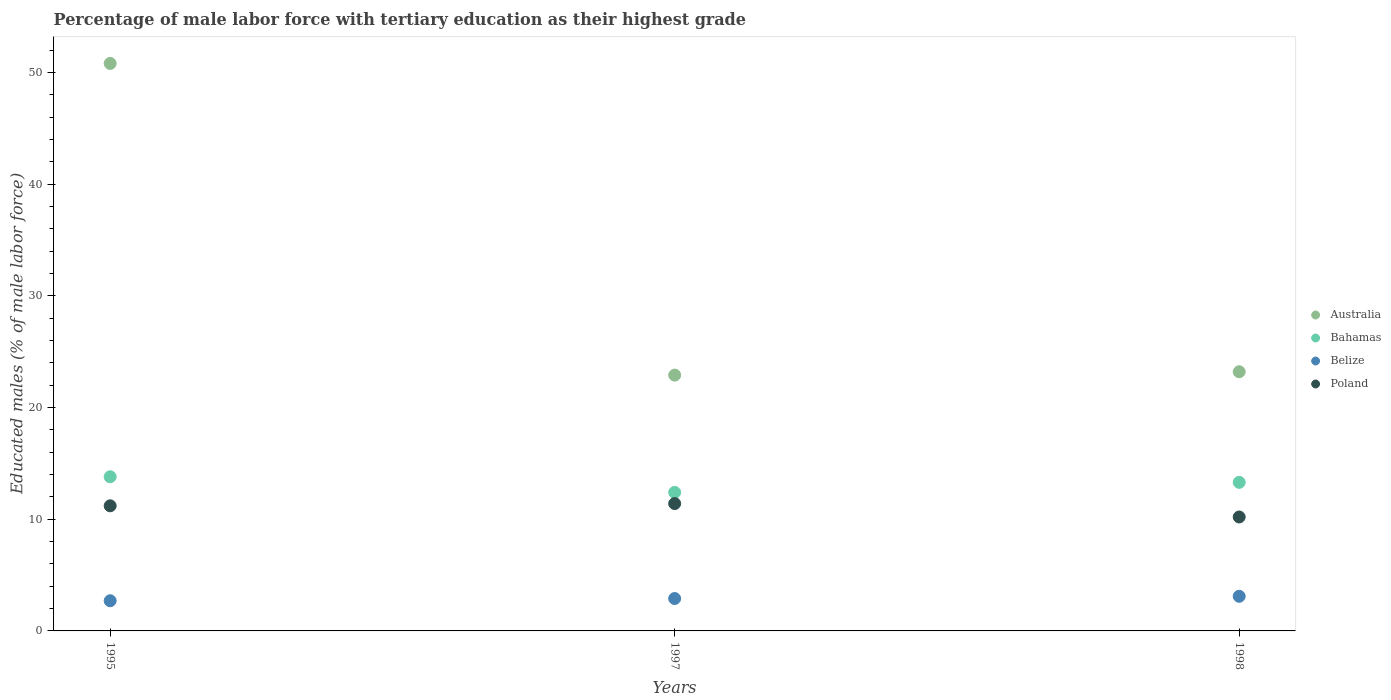How many different coloured dotlines are there?
Provide a short and direct response. 4. What is the percentage of male labor force with tertiary education in Bahamas in 1998?
Offer a very short reply. 13.3. Across all years, what is the maximum percentage of male labor force with tertiary education in Australia?
Offer a terse response. 50.8. Across all years, what is the minimum percentage of male labor force with tertiary education in Belize?
Your answer should be compact. 2.7. What is the total percentage of male labor force with tertiary education in Australia in the graph?
Ensure brevity in your answer.  96.9. What is the difference between the percentage of male labor force with tertiary education in Poland in 1995 and that in 1997?
Provide a succinct answer. -0.2. What is the difference between the percentage of male labor force with tertiary education in Australia in 1998 and the percentage of male labor force with tertiary education in Belize in 1995?
Offer a very short reply. 20.5. What is the average percentage of male labor force with tertiary education in Belize per year?
Provide a succinct answer. 2.9. In the year 1998, what is the difference between the percentage of male labor force with tertiary education in Bahamas and percentage of male labor force with tertiary education in Australia?
Provide a succinct answer. -9.9. What is the ratio of the percentage of male labor force with tertiary education in Belize in 1997 to that in 1998?
Keep it short and to the point. 0.94. Is the difference between the percentage of male labor force with tertiary education in Bahamas in 1997 and 1998 greater than the difference between the percentage of male labor force with tertiary education in Australia in 1997 and 1998?
Provide a succinct answer. No. What is the difference between the highest and the second highest percentage of male labor force with tertiary education in Belize?
Provide a short and direct response. 0.2. What is the difference between the highest and the lowest percentage of male labor force with tertiary education in Poland?
Give a very brief answer. 1.2. In how many years, is the percentage of male labor force with tertiary education in Australia greater than the average percentage of male labor force with tertiary education in Australia taken over all years?
Ensure brevity in your answer.  1. Is it the case that in every year, the sum of the percentage of male labor force with tertiary education in Australia and percentage of male labor force with tertiary education in Bahamas  is greater than the percentage of male labor force with tertiary education in Belize?
Give a very brief answer. Yes. Is the percentage of male labor force with tertiary education in Belize strictly less than the percentage of male labor force with tertiary education in Poland over the years?
Your response must be concise. Yes. Does the graph contain grids?
Make the answer very short. No. How many legend labels are there?
Provide a succinct answer. 4. What is the title of the graph?
Keep it short and to the point. Percentage of male labor force with tertiary education as their highest grade. What is the label or title of the Y-axis?
Provide a short and direct response. Educated males (% of male labor force). What is the Educated males (% of male labor force) of Australia in 1995?
Offer a terse response. 50.8. What is the Educated males (% of male labor force) in Bahamas in 1995?
Provide a succinct answer. 13.8. What is the Educated males (% of male labor force) in Belize in 1995?
Give a very brief answer. 2.7. What is the Educated males (% of male labor force) in Poland in 1995?
Offer a very short reply. 11.2. What is the Educated males (% of male labor force) of Australia in 1997?
Your response must be concise. 22.9. What is the Educated males (% of male labor force) in Bahamas in 1997?
Offer a very short reply. 12.4. What is the Educated males (% of male labor force) of Belize in 1997?
Ensure brevity in your answer.  2.9. What is the Educated males (% of male labor force) in Poland in 1997?
Your answer should be very brief. 11.4. What is the Educated males (% of male labor force) of Australia in 1998?
Provide a succinct answer. 23.2. What is the Educated males (% of male labor force) of Bahamas in 1998?
Offer a terse response. 13.3. What is the Educated males (% of male labor force) of Belize in 1998?
Keep it short and to the point. 3.1. What is the Educated males (% of male labor force) in Poland in 1998?
Your answer should be compact. 10.2. Across all years, what is the maximum Educated males (% of male labor force) of Australia?
Keep it short and to the point. 50.8. Across all years, what is the maximum Educated males (% of male labor force) of Bahamas?
Your answer should be very brief. 13.8. Across all years, what is the maximum Educated males (% of male labor force) of Belize?
Keep it short and to the point. 3.1. Across all years, what is the maximum Educated males (% of male labor force) in Poland?
Your response must be concise. 11.4. Across all years, what is the minimum Educated males (% of male labor force) in Australia?
Provide a succinct answer. 22.9. Across all years, what is the minimum Educated males (% of male labor force) in Bahamas?
Give a very brief answer. 12.4. Across all years, what is the minimum Educated males (% of male labor force) in Belize?
Offer a very short reply. 2.7. Across all years, what is the minimum Educated males (% of male labor force) in Poland?
Your answer should be compact. 10.2. What is the total Educated males (% of male labor force) of Australia in the graph?
Give a very brief answer. 96.9. What is the total Educated males (% of male labor force) of Bahamas in the graph?
Your answer should be very brief. 39.5. What is the total Educated males (% of male labor force) of Belize in the graph?
Offer a terse response. 8.7. What is the total Educated males (% of male labor force) of Poland in the graph?
Keep it short and to the point. 32.8. What is the difference between the Educated males (% of male labor force) in Australia in 1995 and that in 1997?
Provide a succinct answer. 27.9. What is the difference between the Educated males (% of male labor force) in Bahamas in 1995 and that in 1997?
Your answer should be very brief. 1.4. What is the difference between the Educated males (% of male labor force) in Poland in 1995 and that in 1997?
Your answer should be very brief. -0.2. What is the difference between the Educated males (% of male labor force) in Australia in 1995 and that in 1998?
Your answer should be very brief. 27.6. What is the difference between the Educated males (% of male labor force) in Belize in 1995 and that in 1998?
Keep it short and to the point. -0.4. What is the difference between the Educated males (% of male labor force) of Poland in 1995 and that in 1998?
Make the answer very short. 1. What is the difference between the Educated males (% of male labor force) of Bahamas in 1997 and that in 1998?
Your answer should be compact. -0.9. What is the difference between the Educated males (% of male labor force) in Australia in 1995 and the Educated males (% of male labor force) in Bahamas in 1997?
Your answer should be very brief. 38.4. What is the difference between the Educated males (% of male labor force) of Australia in 1995 and the Educated males (% of male labor force) of Belize in 1997?
Offer a very short reply. 47.9. What is the difference between the Educated males (% of male labor force) of Australia in 1995 and the Educated males (% of male labor force) of Poland in 1997?
Offer a very short reply. 39.4. What is the difference between the Educated males (% of male labor force) in Belize in 1995 and the Educated males (% of male labor force) in Poland in 1997?
Your answer should be compact. -8.7. What is the difference between the Educated males (% of male labor force) of Australia in 1995 and the Educated males (% of male labor force) of Bahamas in 1998?
Ensure brevity in your answer.  37.5. What is the difference between the Educated males (% of male labor force) of Australia in 1995 and the Educated males (% of male labor force) of Belize in 1998?
Give a very brief answer. 47.7. What is the difference between the Educated males (% of male labor force) of Australia in 1995 and the Educated males (% of male labor force) of Poland in 1998?
Give a very brief answer. 40.6. What is the difference between the Educated males (% of male labor force) in Bahamas in 1995 and the Educated males (% of male labor force) in Belize in 1998?
Your answer should be very brief. 10.7. What is the difference between the Educated males (% of male labor force) in Bahamas in 1995 and the Educated males (% of male labor force) in Poland in 1998?
Provide a succinct answer. 3.6. What is the difference between the Educated males (% of male labor force) of Australia in 1997 and the Educated males (% of male labor force) of Bahamas in 1998?
Ensure brevity in your answer.  9.6. What is the difference between the Educated males (% of male labor force) of Australia in 1997 and the Educated males (% of male labor force) of Belize in 1998?
Your answer should be compact. 19.8. What is the difference between the Educated males (% of male labor force) of Australia in 1997 and the Educated males (% of male labor force) of Poland in 1998?
Keep it short and to the point. 12.7. What is the difference between the Educated males (% of male labor force) in Bahamas in 1997 and the Educated males (% of male labor force) in Poland in 1998?
Give a very brief answer. 2.2. What is the average Educated males (% of male labor force) of Australia per year?
Give a very brief answer. 32.3. What is the average Educated males (% of male labor force) of Bahamas per year?
Keep it short and to the point. 13.17. What is the average Educated males (% of male labor force) of Poland per year?
Provide a succinct answer. 10.93. In the year 1995, what is the difference between the Educated males (% of male labor force) in Australia and Educated males (% of male labor force) in Bahamas?
Ensure brevity in your answer.  37. In the year 1995, what is the difference between the Educated males (% of male labor force) in Australia and Educated males (% of male labor force) in Belize?
Offer a terse response. 48.1. In the year 1995, what is the difference between the Educated males (% of male labor force) of Australia and Educated males (% of male labor force) of Poland?
Give a very brief answer. 39.6. In the year 1997, what is the difference between the Educated males (% of male labor force) in Australia and Educated males (% of male labor force) in Bahamas?
Provide a short and direct response. 10.5. In the year 1997, what is the difference between the Educated males (% of male labor force) in Australia and Educated males (% of male labor force) in Belize?
Give a very brief answer. 20. In the year 1997, what is the difference between the Educated males (% of male labor force) in Australia and Educated males (% of male labor force) in Poland?
Provide a succinct answer. 11.5. In the year 1997, what is the difference between the Educated males (% of male labor force) in Bahamas and Educated males (% of male labor force) in Poland?
Provide a short and direct response. 1. In the year 1998, what is the difference between the Educated males (% of male labor force) in Australia and Educated males (% of male labor force) in Belize?
Ensure brevity in your answer.  20.1. In the year 1998, what is the difference between the Educated males (% of male labor force) of Australia and Educated males (% of male labor force) of Poland?
Offer a terse response. 13. What is the ratio of the Educated males (% of male labor force) of Australia in 1995 to that in 1997?
Ensure brevity in your answer.  2.22. What is the ratio of the Educated males (% of male labor force) of Bahamas in 1995 to that in 1997?
Your answer should be compact. 1.11. What is the ratio of the Educated males (% of male labor force) of Belize in 1995 to that in 1997?
Offer a very short reply. 0.93. What is the ratio of the Educated males (% of male labor force) in Poland in 1995 to that in 1997?
Your answer should be very brief. 0.98. What is the ratio of the Educated males (% of male labor force) in Australia in 1995 to that in 1998?
Ensure brevity in your answer.  2.19. What is the ratio of the Educated males (% of male labor force) of Bahamas in 1995 to that in 1998?
Your answer should be very brief. 1.04. What is the ratio of the Educated males (% of male labor force) in Belize in 1995 to that in 1998?
Provide a short and direct response. 0.87. What is the ratio of the Educated males (% of male labor force) in Poland in 1995 to that in 1998?
Keep it short and to the point. 1.1. What is the ratio of the Educated males (% of male labor force) of Australia in 1997 to that in 1998?
Your response must be concise. 0.99. What is the ratio of the Educated males (% of male labor force) in Bahamas in 1997 to that in 1998?
Keep it short and to the point. 0.93. What is the ratio of the Educated males (% of male labor force) of Belize in 1997 to that in 1998?
Offer a terse response. 0.94. What is the ratio of the Educated males (% of male labor force) in Poland in 1997 to that in 1998?
Your answer should be very brief. 1.12. What is the difference between the highest and the second highest Educated males (% of male labor force) in Australia?
Your answer should be compact. 27.6. What is the difference between the highest and the second highest Educated males (% of male labor force) in Bahamas?
Offer a terse response. 0.5. What is the difference between the highest and the second highest Educated males (% of male labor force) of Belize?
Your response must be concise. 0.2. What is the difference between the highest and the lowest Educated males (% of male labor force) in Australia?
Your answer should be compact. 27.9. What is the difference between the highest and the lowest Educated males (% of male labor force) of Belize?
Ensure brevity in your answer.  0.4. 